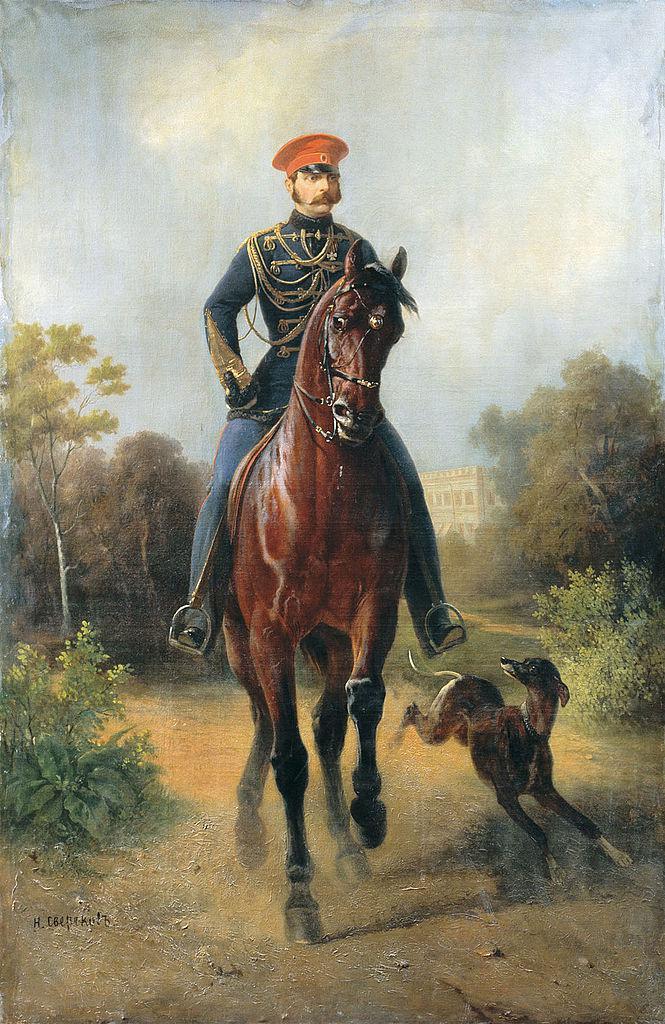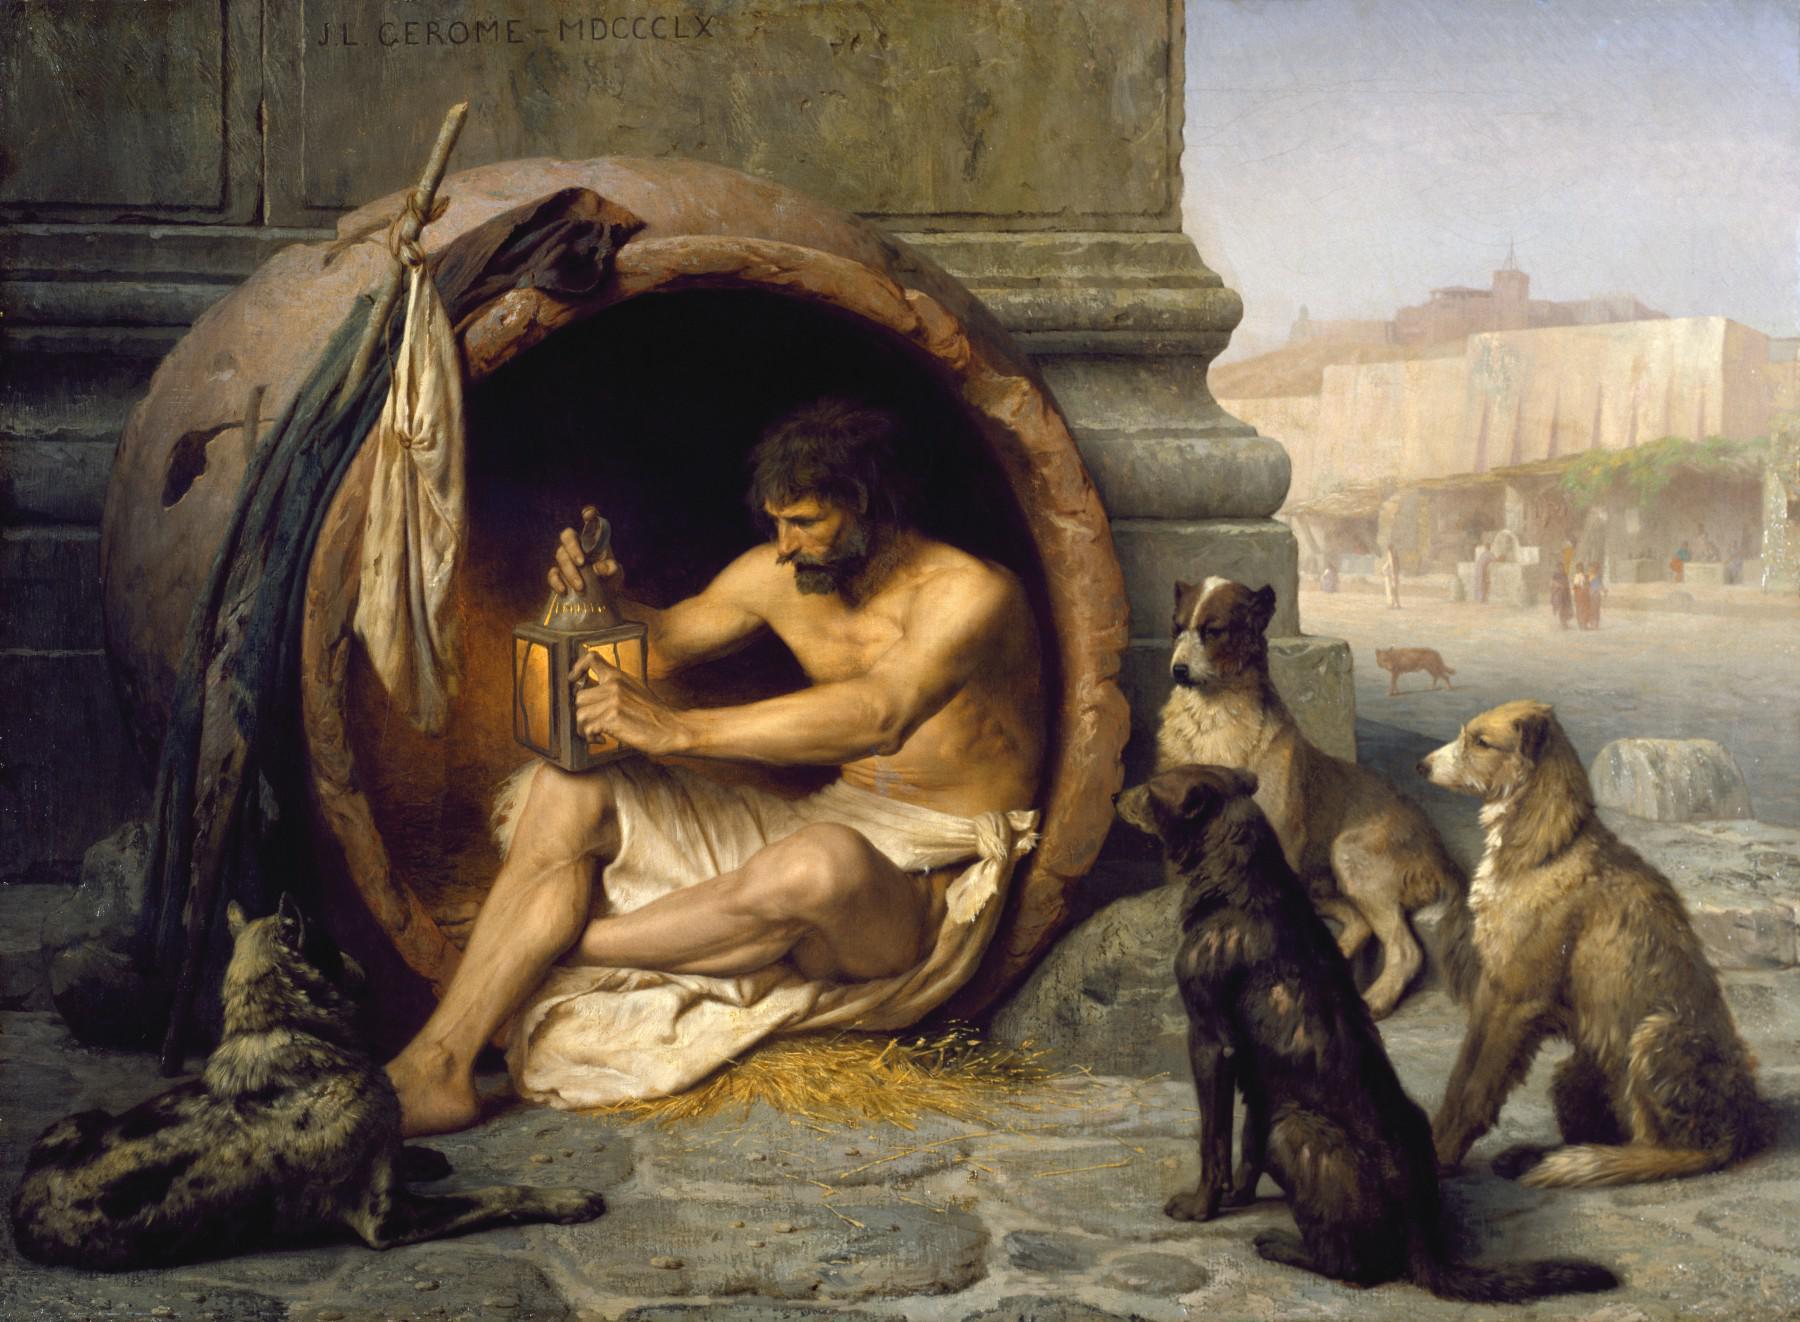The first image is the image on the left, the second image is the image on the right. Analyze the images presented: Is the assertion "There is at least one horse in the same image as a man." valid? Answer yes or no. Yes. 